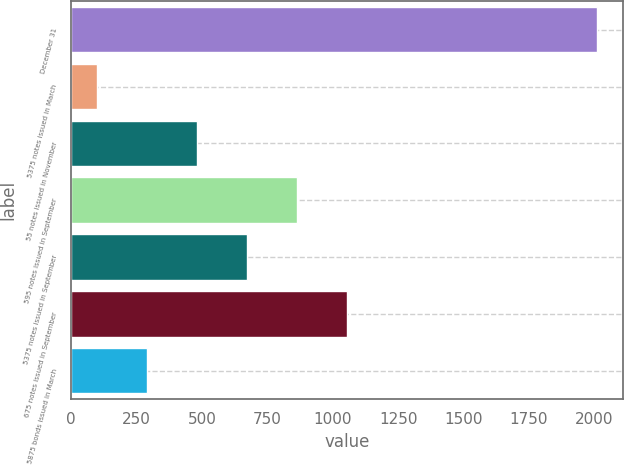Convert chart to OTSL. <chart><loc_0><loc_0><loc_500><loc_500><bar_chart><fcel>December 31<fcel>5375 notes issued in March<fcel>55 notes issued in November<fcel>595 notes issued in September<fcel>5375 notes issued in September<fcel>675 notes issued in September<fcel>5875 bonds issued in March<nl><fcel>2009<fcel>100<fcel>481.8<fcel>863.6<fcel>672.7<fcel>1054.5<fcel>290.9<nl></chart> 